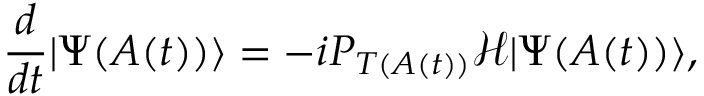Convert formula to latex. <formula><loc_0><loc_0><loc_500><loc_500>\frac { d } { d t } | \Psi ( A ( t ) ) \rangle = - i P _ { T ( A ( t ) ) } \mathcal { H } | \Psi ( A ( t ) ) \rangle ,</formula> 